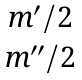<formula> <loc_0><loc_0><loc_500><loc_500>\begin{matrix} { m ^ { \prime } / 2 } \\ { m ^ { \prime \prime } / 2 } \end{matrix}</formula> 